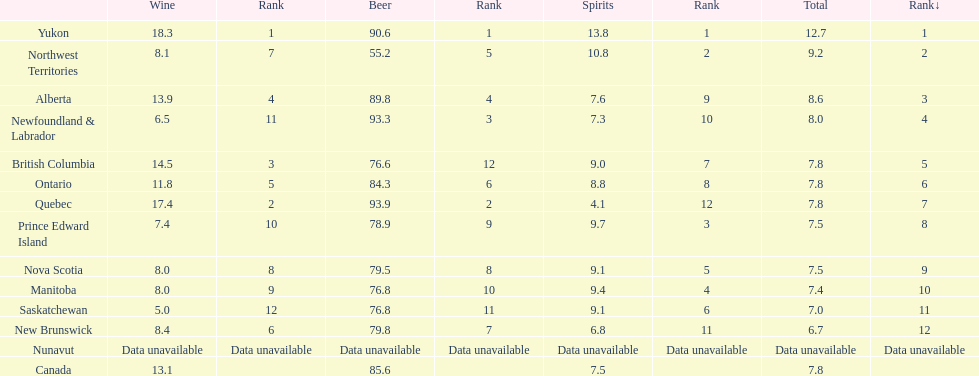What are the locations where the total alcohol consumption is the same as another location? British Columbia, Ontario, Quebec, Prince Edward Island, Nova Scotia. Which of these locations have a beer consumption exceeding 80? Ontario, Quebec. Out of these, what is the spirit consumption for the location with the maximum beer consumption? 4.1. 